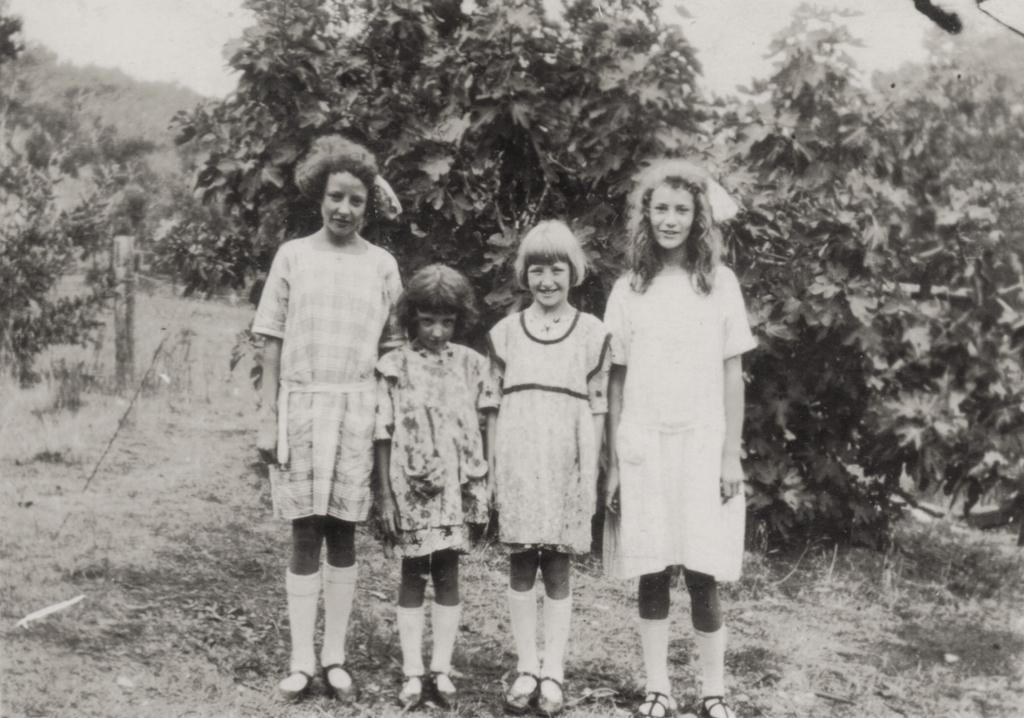What is the color scheme of the image? The image is black and white. How many kids are present in the image? There are four kids standing on the ground. How are the kids positioned in relation to each other? The kids are standing one beside the other. What can be seen in the background of the image? There are trees in the background of the image. What type of ground is visible in the image? There is grass and sand on the ground. What type of guitar can be seen being played by one of the kids in the image? There is no guitar present in the image; it is a black and white image of four kids standing on the ground with trees in the background. 